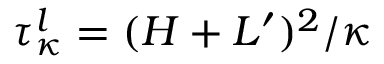Convert formula to latex. <formula><loc_0><loc_0><loc_500><loc_500>\tau _ { \kappa } ^ { l } = ( H + L ^ { \prime } ) ^ { 2 } / \kappa</formula> 